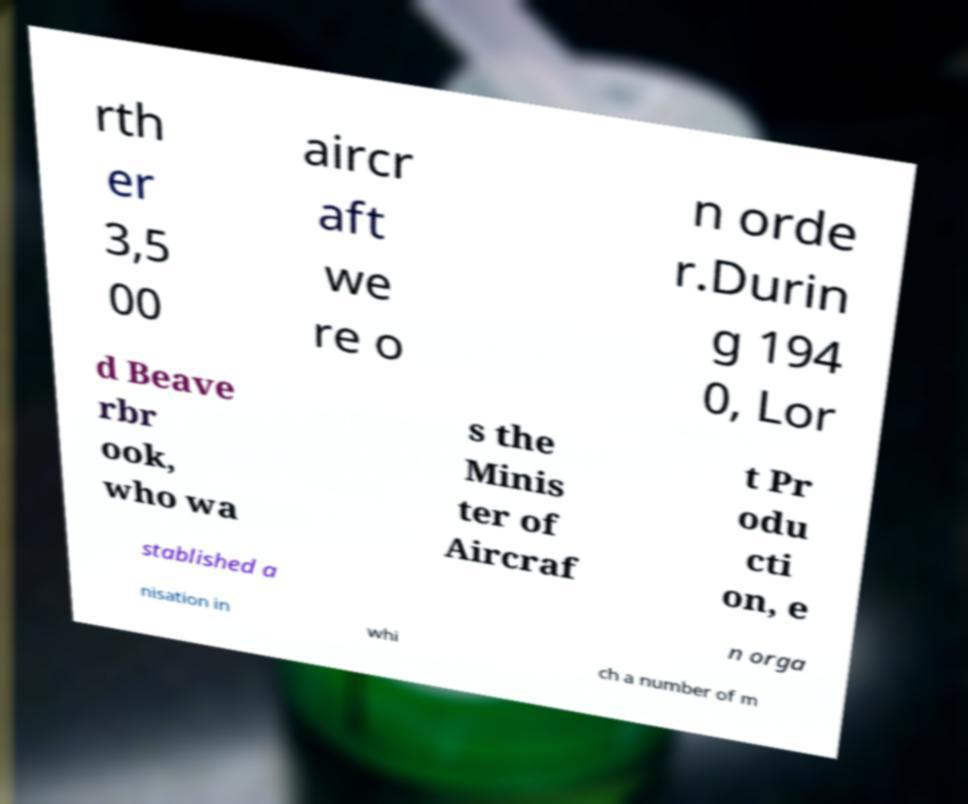I need the written content from this picture converted into text. Can you do that? rth er 3,5 00 aircr aft we re o n orde r.Durin g 194 0, Lor d Beave rbr ook, who wa s the Minis ter of Aircraf t Pr odu cti on, e stablished a n orga nisation in whi ch a number of m 